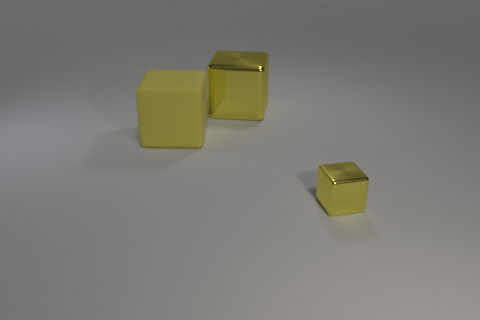Is the number of large metal objects that are in front of the big metal cube the same as the number of small yellow cubes on the left side of the large yellow matte object? In the image provided, it appears that there are no large metal objects in front of any big metal cube, nor are there any small yellow cubes on the left side of a large yellow matte object. The image actually shows three small yellow cubes on a surface, without any large metal cube or large yellow matte object in sight. Based on this observation, the question does not accurately reflect the contents of the image, so a direct comparison as stated in the question can't be made. If you could clarify or adjust your question, I'd be glad to help analyze the scene further! 